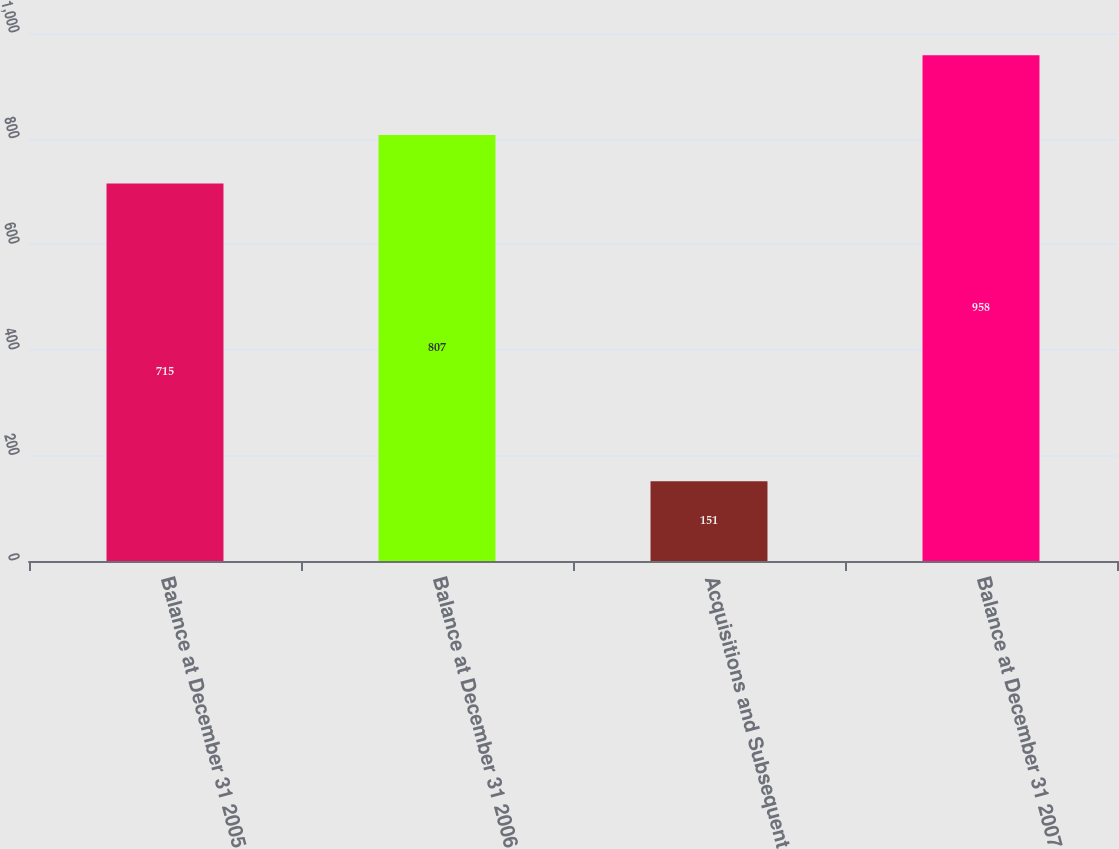Convert chart. <chart><loc_0><loc_0><loc_500><loc_500><bar_chart><fcel>Balance at December 31 2005<fcel>Balance at December 31 2006<fcel>Acquisitions and Subsequent<fcel>Balance at December 31 2007<nl><fcel>715<fcel>807<fcel>151<fcel>958<nl></chart> 